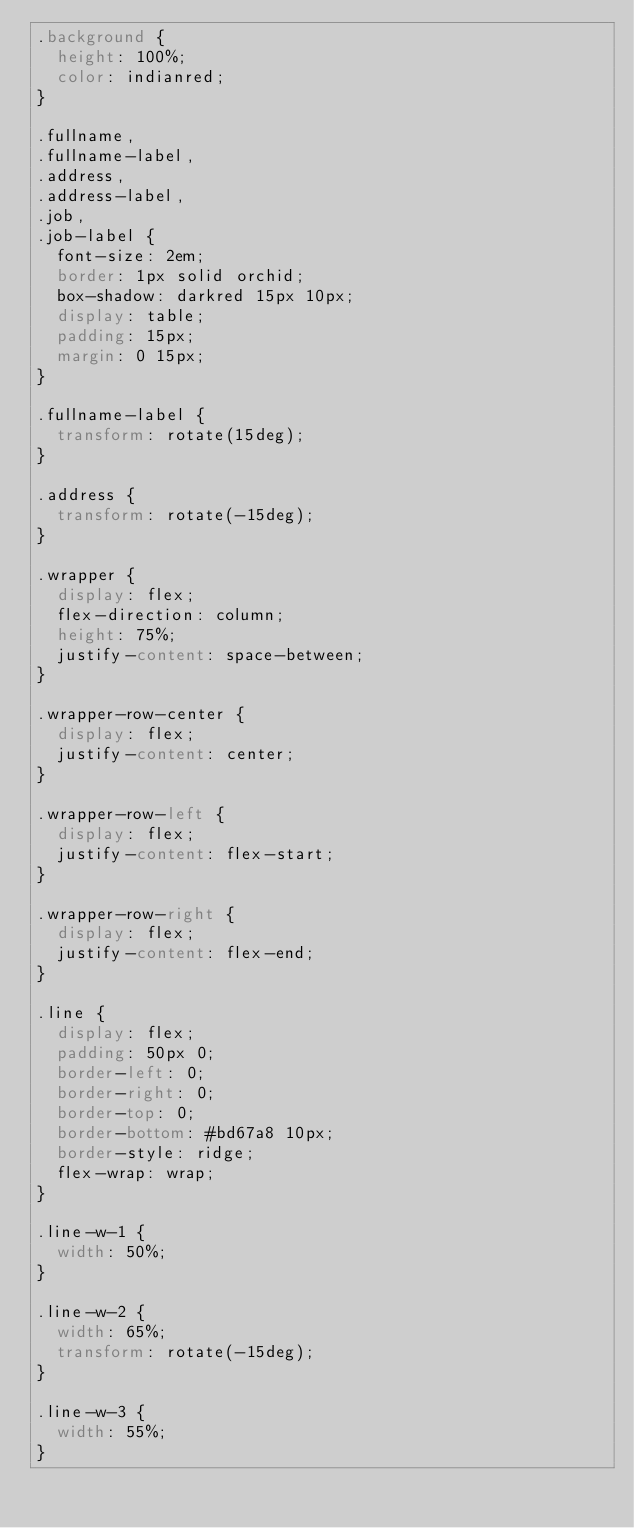<code> <loc_0><loc_0><loc_500><loc_500><_CSS_>.background {
  height: 100%;
  color: indianred;
}

.fullname,
.fullname-label,
.address,
.address-label,
.job,
.job-label {
  font-size: 2em;
  border: 1px solid orchid;
  box-shadow: darkred 15px 10px;
  display: table;
  padding: 15px;
  margin: 0 15px;
}

.fullname-label {
  transform: rotate(15deg);
}

.address {
  transform: rotate(-15deg);
}

.wrapper {
  display: flex;
  flex-direction: column;
  height: 75%;
  justify-content: space-between;
}

.wrapper-row-center {
  display: flex;
  justify-content: center;
}

.wrapper-row-left {
  display: flex;
  justify-content: flex-start;
}

.wrapper-row-right {
  display: flex;
  justify-content: flex-end;
}

.line {
  display: flex;
  padding: 50px 0;
  border-left: 0;
  border-right: 0;
  border-top: 0;
  border-bottom: #bd67a8 10px;
  border-style: ridge;
  flex-wrap: wrap;
}

.line-w-1 {
  width: 50%;
}

.line-w-2 {
  width: 65%;
  transform: rotate(-15deg);
}

.line-w-3 {
  width: 55%;
}
</code> 